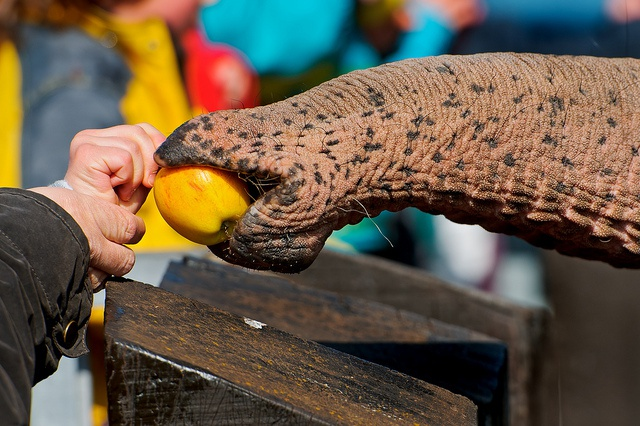Describe the objects in this image and their specific colors. I can see elephant in brown, black, gray, and tan tones, people in brown, gray, orange, and maroon tones, people in brown, black, lightpink, maroon, and gray tones, and apple in brown, orange, maroon, gold, and red tones in this image. 